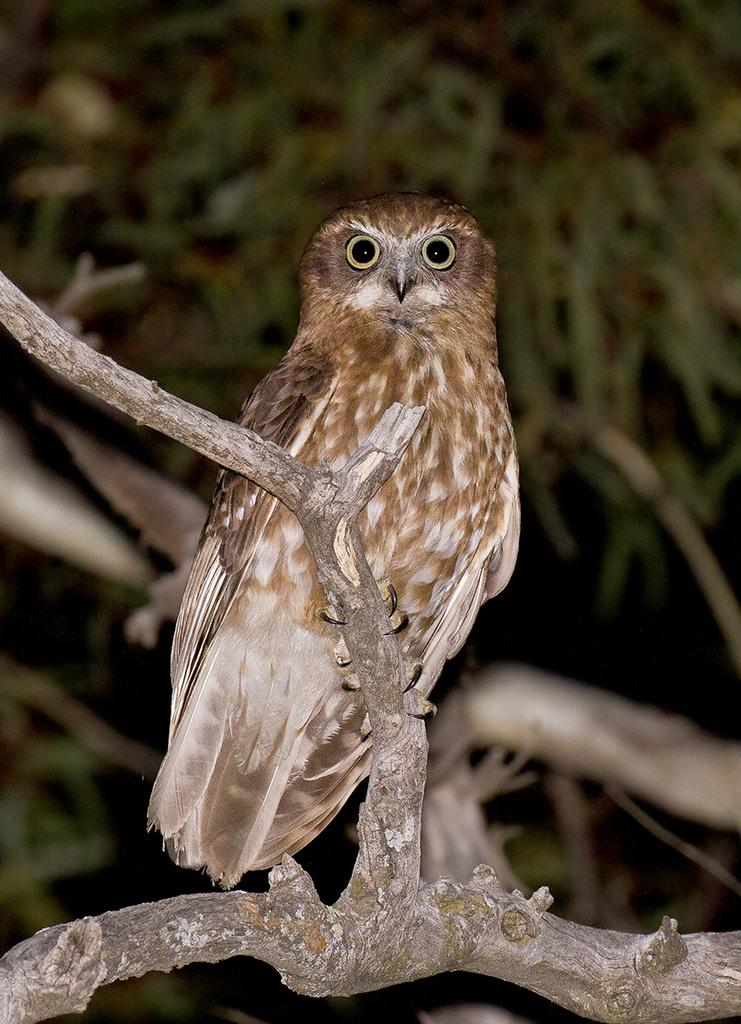What animal can be seen in the image? There is an owl in the image. Where is the owl located? The owl is on a tree stem. What can be seen in the background of the image? There are leaves and stems in the background of the image. How would you describe the lighting in the image? The background of the image is dark. What type of wood is the owl perched on in the image? The facts provided do not mention any specific type of wood; the owl is simply on a tree stem. Is there a vase visible in the image? No, there is no vase present in the image. What is the owl holding in its talons in the image? The facts provided do not mention any object being held by the owl. What type of fruit is present in the image? The facts provided do not mention any fruit in the image. What type of quince is the owl holding in its talons in the image? There is no quince present in the image, and the owl is not holding anything in its talons. 